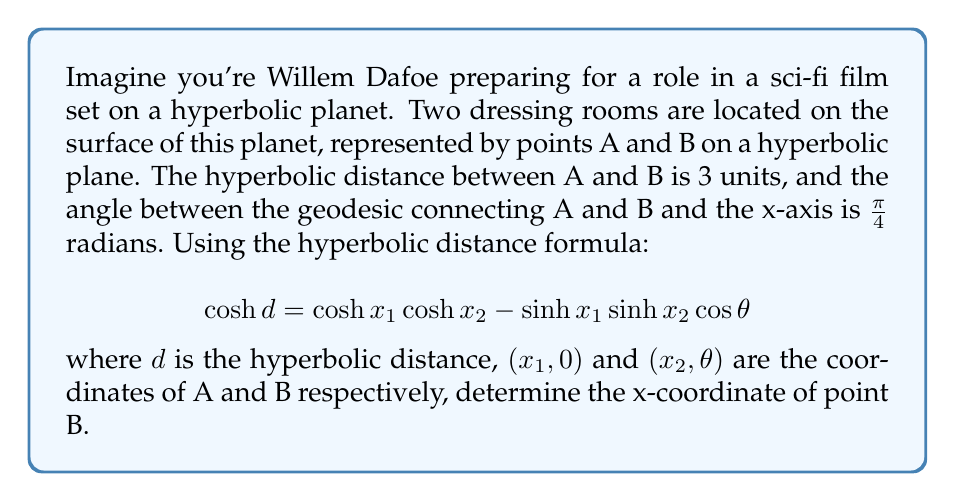Can you answer this question? Let's approach this step-by-step:

1) We're given that the hyperbolic distance $d = 3$ and the angle $\theta = \frac{\pi}{4}$.

2) We need to find $x_2$, which is the x-coordinate of point B. Let's assume point A is at $(x_1, 0)$.

3) We can use the hyperbolic distance formula:

   $$ \cosh d = \cosh x_1 \cosh x_2 - \sinh x_1 \sinh x_2 \cos \theta $$

4) Substituting the known values:

   $$ \cosh 3 = \cosh x_1 \cosh x_2 - \sinh x_1 \sinh x_2 \cos \frac{\pi}{4} $$

5) We know that $\cos \frac{\pi}{4} = \frac{\sqrt{2}}{2}$, so:

   $$ \cosh 3 = \cosh x_1 \cosh x_2 - \sinh x_1 \sinh x_2 \frac{\sqrt{2}}{2} $$

6) Now, we need to find a relationship between $x_1$ and $x_2$. In a hyperbolic plane, the shortest path (geodesic) between two points is symmetric about the perpendicular bisector of the line connecting them. This means $x_1 = x_2$.

7) Let's call this common value $x$. Substituting into our equation:

   $$ \cosh 3 = \cosh^2 x - \sinh^2 x \frac{\sqrt{2}}{2} $$

8) We know that $\cosh^2 x - \sinh^2 x = 1$, so:

   $$ \cosh 3 = 1 + \sinh^2 x (1 - \frac{\sqrt{2}}{2}) $$

9) Solving for $\sinh^2 x$:

   $$ \sinh^2 x = \frac{\cosh 3 - 1}{1 - \frac{\sqrt{2}}{2}} $$

10) Taking the square root and then the inverse hyperbolic sine:

    $$ x = \sinh^{-1} \sqrt{\frac{\cosh 3 - 1}{1 - \frac{\sqrt{2}}{2}}} $$

11) Calculating this value (you can use a calculator):

    $x \approx 2.014$

Therefore, the x-coordinate of point B is approximately 2.014 units.
Answer: $x_2 \approx 2.014$ 